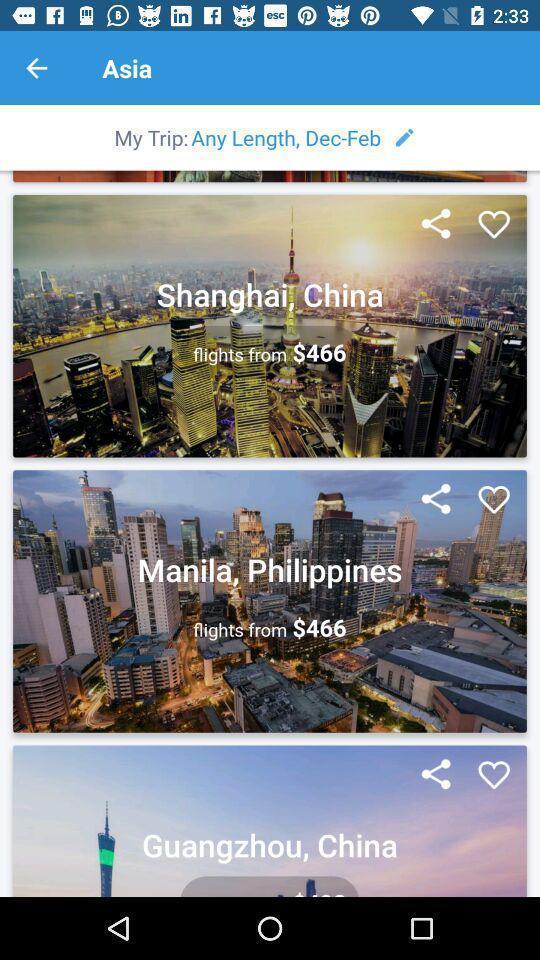Explain what's happening in this screen capture. Various flight details displayed of a booking app. 